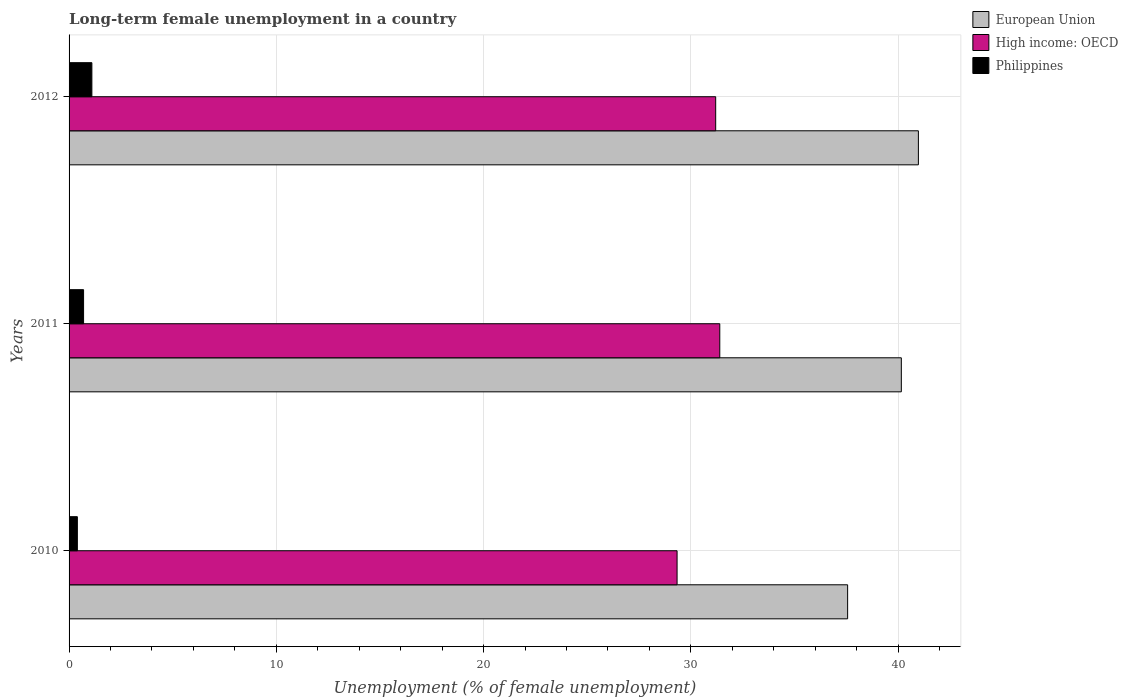Are the number of bars per tick equal to the number of legend labels?
Keep it short and to the point. Yes. Are the number of bars on each tick of the Y-axis equal?
Offer a terse response. Yes. How many bars are there on the 3rd tick from the bottom?
Keep it short and to the point. 3. What is the label of the 1st group of bars from the top?
Keep it short and to the point. 2012. What is the percentage of long-term unemployed female population in High income: OECD in 2011?
Ensure brevity in your answer.  31.4. Across all years, what is the maximum percentage of long-term unemployed female population in European Union?
Offer a very short reply. 40.98. Across all years, what is the minimum percentage of long-term unemployed female population in High income: OECD?
Your answer should be very brief. 29.34. In which year was the percentage of long-term unemployed female population in High income: OECD maximum?
Your response must be concise. 2011. In which year was the percentage of long-term unemployed female population in European Union minimum?
Your response must be concise. 2010. What is the total percentage of long-term unemployed female population in High income: OECD in the graph?
Your response must be concise. 91.93. What is the difference between the percentage of long-term unemployed female population in High income: OECD in 2010 and that in 2011?
Provide a succinct answer. -2.06. What is the difference between the percentage of long-term unemployed female population in European Union in 2010 and the percentage of long-term unemployed female population in Philippines in 2011?
Ensure brevity in your answer.  36.87. What is the average percentage of long-term unemployed female population in Philippines per year?
Your response must be concise. 0.73. In the year 2012, what is the difference between the percentage of long-term unemployed female population in European Union and percentage of long-term unemployed female population in High income: OECD?
Ensure brevity in your answer.  9.78. In how many years, is the percentage of long-term unemployed female population in High income: OECD greater than 18 %?
Your response must be concise. 3. What is the ratio of the percentage of long-term unemployed female population in High income: OECD in 2011 to that in 2012?
Provide a short and direct response. 1.01. Is the percentage of long-term unemployed female population in High income: OECD in 2011 less than that in 2012?
Your answer should be very brief. No. Is the difference between the percentage of long-term unemployed female population in European Union in 2011 and 2012 greater than the difference between the percentage of long-term unemployed female population in High income: OECD in 2011 and 2012?
Make the answer very short. No. What is the difference between the highest and the second highest percentage of long-term unemployed female population in European Union?
Ensure brevity in your answer.  0.82. What is the difference between the highest and the lowest percentage of long-term unemployed female population in Philippines?
Your answer should be compact. 0.7. In how many years, is the percentage of long-term unemployed female population in Philippines greater than the average percentage of long-term unemployed female population in Philippines taken over all years?
Keep it short and to the point. 1. What does the 2nd bar from the top in 2010 represents?
Your answer should be very brief. High income: OECD. What does the 2nd bar from the bottom in 2012 represents?
Your answer should be compact. High income: OECD. Is it the case that in every year, the sum of the percentage of long-term unemployed female population in Philippines and percentage of long-term unemployed female population in High income: OECD is greater than the percentage of long-term unemployed female population in European Union?
Offer a terse response. No. Are the values on the major ticks of X-axis written in scientific E-notation?
Your response must be concise. No. Does the graph contain any zero values?
Ensure brevity in your answer.  No. Does the graph contain grids?
Your answer should be very brief. Yes. What is the title of the graph?
Offer a very short reply. Long-term female unemployment in a country. Does "Ukraine" appear as one of the legend labels in the graph?
Your answer should be very brief. No. What is the label or title of the X-axis?
Your response must be concise. Unemployment (% of female unemployment). What is the label or title of the Y-axis?
Your answer should be compact. Years. What is the Unemployment (% of female unemployment) in European Union in 2010?
Give a very brief answer. 37.57. What is the Unemployment (% of female unemployment) of High income: OECD in 2010?
Keep it short and to the point. 29.34. What is the Unemployment (% of female unemployment) in Philippines in 2010?
Ensure brevity in your answer.  0.4. What is the Unemployment (% of female unemployment) of European Union in 2011?
Your response must be concise. 40.16. What is the Unemployment (% of female unemployment) in High income: OECD in 2011?
Your response must be concise. 31.4. What is the Unemployment (% of female unemployment) in Philippines in 2011?
Provide a succinct answer. 0.7. What is the Unemployment (% of female unemployment) of European Union in 2012?
Your response must be concise. 40.98. What is the Unemployment (% of female unemployment) of High income: OECD in 2012?
Offer a very short reply. 31.2. What is the Unemployment (% of female unemployment) of Philippines in 2012?
Ensure brevity in your answer.  1.1. Across all years, what is the maximum Unemployment (% of female unemployment) of European Union?
Your response must be concise. 40.98. Across all years, what is the maximum Unemployment (% of female unemployment) in High income: OECD?
Your answer should be compact. 31.4. Across all years, what is the maximum Unemployment (% of female unemployment) of Philippines?
Provide a short and direct response. 1.1. Across all years, what is the minimum Unemployment (% of female unemployment) of European Union?
Your answer should be compact. 37.57. Across all years, what is the minimum Unemployment (% of female unemployment) of High income: OECD?
Your response must be concise. 29.34. Across all years, what is the minimum Unemployment (% of female unemployment) of Philippines?
Your response must be concise. 0.4. What is the total Unemployment (% of female unemployment) in European Union in the graph?
Keep it short and to the point. 118.7. What is the total Unemployment (% of female unemployment) in High income: OECD in the graph?
Make the answer very short. 91.93. What is the difference between the Unemployment (% of female unemployment) of European Union in 2010 and that in 2011?
Your answer should be very brief. -2.59. What is the difference between the Unemployment (% of female unemployment) in High income: OECD in 2010 and that in 2011?
Your response must be concise. -2.06. What is the difference between the Unemployment (% of female unemployment) of European Union in 2010 and that in 2012?
Offer a terse response. -3.41. What is the difference between the Unemployment (% of female unemployment) in High income: OECD in 2010 and that in 2012?
Offer a very short reply. -1.86. What is the difference between the Unemployment (% of female unemployment) in Philippines in 2010 and that in 2012?
Offer a very short reply. -0.7. What is the difference between the Unemployment (% of female unemployment) in European Union in 2011 and that in 2012?
Offer a very short reply. -0.82. What is the difference between the Unemployment (% of female unemployment) of High income: OECD in 2011 and that in 2012?
Your response must be concise. 0.2. What is the difference between the Unemployment (% of female unemployment) in European Union in 2010 and the Unemployment (% of female unemployment) in High income: OECD in 2011?
Your answer should be compact. 6.17. What is the difference between the Unemployment (% of female unemployment) of European Union in 2010 and the Unemployment (% of female unemployment) of Philippines in 2011?
Your answer should be very brief. 36.87. What is the difference between the Unemployment (% of female unemployment) of High income: OECD in 2010 and the Unemployment (% of female unemployment) of Philippines in 2011?
Ensure brevity in your answer.  28.64. What is the difference between the Unemployment (% of female unemployment) in European Union in 2010 and the Unemployment (% of female unemployment) in High income: OECD in 2012?
Ensure brevity in your answer.  6.37. What is the difference between the Unemployment (% of female unemployment) of European Union in 2010 and the Unemployment (% of female unemployment) of Philippines in 2012?
Offer a very short reply. 36.47. What is the difference between the Unemployment (% of female unemployment) of High income: OECD in 2010 and the Unemployment (% of female unemployment) of Philippines in 2012?
Offer a terse response. 28.24. What is the difference between the Unemployment (% of female unemployment) in European Union in 2011 and the Unemployment (% of female unemployment) in High income: OECD in 2012?
Keep it short and to the point. 8.96. What is the difference between the Unemployment (% of female unemployment) in European Union in 2011 and the Unemployment (% of female unemployment) in Philippines in 2012?
Your answer should be very brief. 39.06. What is the difference between the Unemployment (% of female unemployment) in High income: OECD in 2011 and the Unemployment (% of female unemployment) in Philippines in 2012?
Offer a terse response. 30.3. What is the average Unemployment (% of female unemployment) in European Union per year?
Ensure brevity in your answer.  39.57. What is the average Unemployment (% of female unemployment) in High income: OECD per year?
Your response must be concise. 30.64. What is the average Unemployment (% of female unemployment) of Philippines per year?
Offer a very short reply. 0.73. In the year 2010, what is the difference between the Unemployment (% of female unemployment) of European Union and Unemployment (% of female unemployment) of High income: OECD?
Ensure brevity in your answer.  8.23. In the year 2010, what is the difference between the Unemployment (% of female unemployment) of European Union and Unemployment (% of female unemployment) of Philippines?
Your answer should be compact. 37.17. In the year 2010, what is the difference between the Unemployment (% of female unemployment) in High income: OECD and Unemployment (% of female unemployment) in Philippines?
Keep it short and to the point. 28.94. In the year 2011, what is the difference between the Unemployment (% of female unemployment) in European Union and Unemployment (% of female unemployment) in High income: OECD?
Your answer should be very brief. 8.76. In the year 2011, what is the difference between the Unemployment (% of female unemployment) in European Union and Unemployment (% of female unemployment) in Philippines?
Provide a succinct answer. 39.46. In the year 2011, what is the difference between the Unemployment (% of female unemployment) in High income: OECD and Unemployment (% of female unemployment) in Philippines?
Your answer should be very brief. 30.7. In the year 2012, what is the difference between the Unemployment (% of female unemployment) of European Union and Unemployment (% of female unemployment) of High income: OECD?
Your answer should be compact. 9.78. In the year 2012, what is the difference between the Unemployment (% of female unemployment) in European Union and Unemployment (% of female unemployment) in Philippines?
Your response must be concise. 39.88. In the year 2012, what is the difference between the Unemployment (% of female unemployment) of High income: OECD and Unemployment (% of female unemployment) of Philippines?
Keep it short and to the point. 30.1. What is the ratio of the Unemployment (% of female unemployment) of European Union in 2010 to that in 2011?
Provide a succinct answer. 0.94. What is the ratio of the Unemployment (% of female unemployment) of High income: OECD in 2010 to that in 2011?
Offer a terse response. 0.93. What is the ratio of the Unemployment (% of female unemployment) in Philippines in 2010 to that in 2011?
Provide a succinct answer. 0.57. What is the ratio of the Unemployment (% of female unemployment) in High income: OECD in 2010 to that in 2012?
Ensure brevity in your answer.  0.94. What is the ratio of the Unemployment (% of female unemployment) of Philippines in 2010 to that in 2012?
Give a very brief answer. 0.36. What is the ratio of the Unemployment (% of female unemployment) of European Union in 2011 to that in 2012?
Your response must be concise. 0.98. What is the ratio of the Unemployment (% of female unemployment) in High income: OECD in 2011 to that in 2012?
Offer a terse response. 1.01. What is the ratio of the Unemployment (% of female unemployment) in Philippines in 2011 to that in 2012?
Offer a very short reply. 0.64. What is the difference between the highest and the second highest Unemployment (% of female unemployment) in European Union?
Ensure brevity in your answer.  0.82. What is the difference between the highest and the second highest Unemployment (% of female unemployment) in High income: OECD?
Provide a succinct answer. 0.2. What is the difference between the highest and the lowest Unemployment (% of female unemployment) of European Union?
Provide a succinct answer. 3.41. What is the difference between the highest and the lowest Unemployment (% of female unemployment) of High income: OECD?
Make the answer very short. 2.06. What is the difference between the highest and the lowest Unemployment (% of female unemployment) in Philippines?
Ensure brevity in your answer.  0.7. 